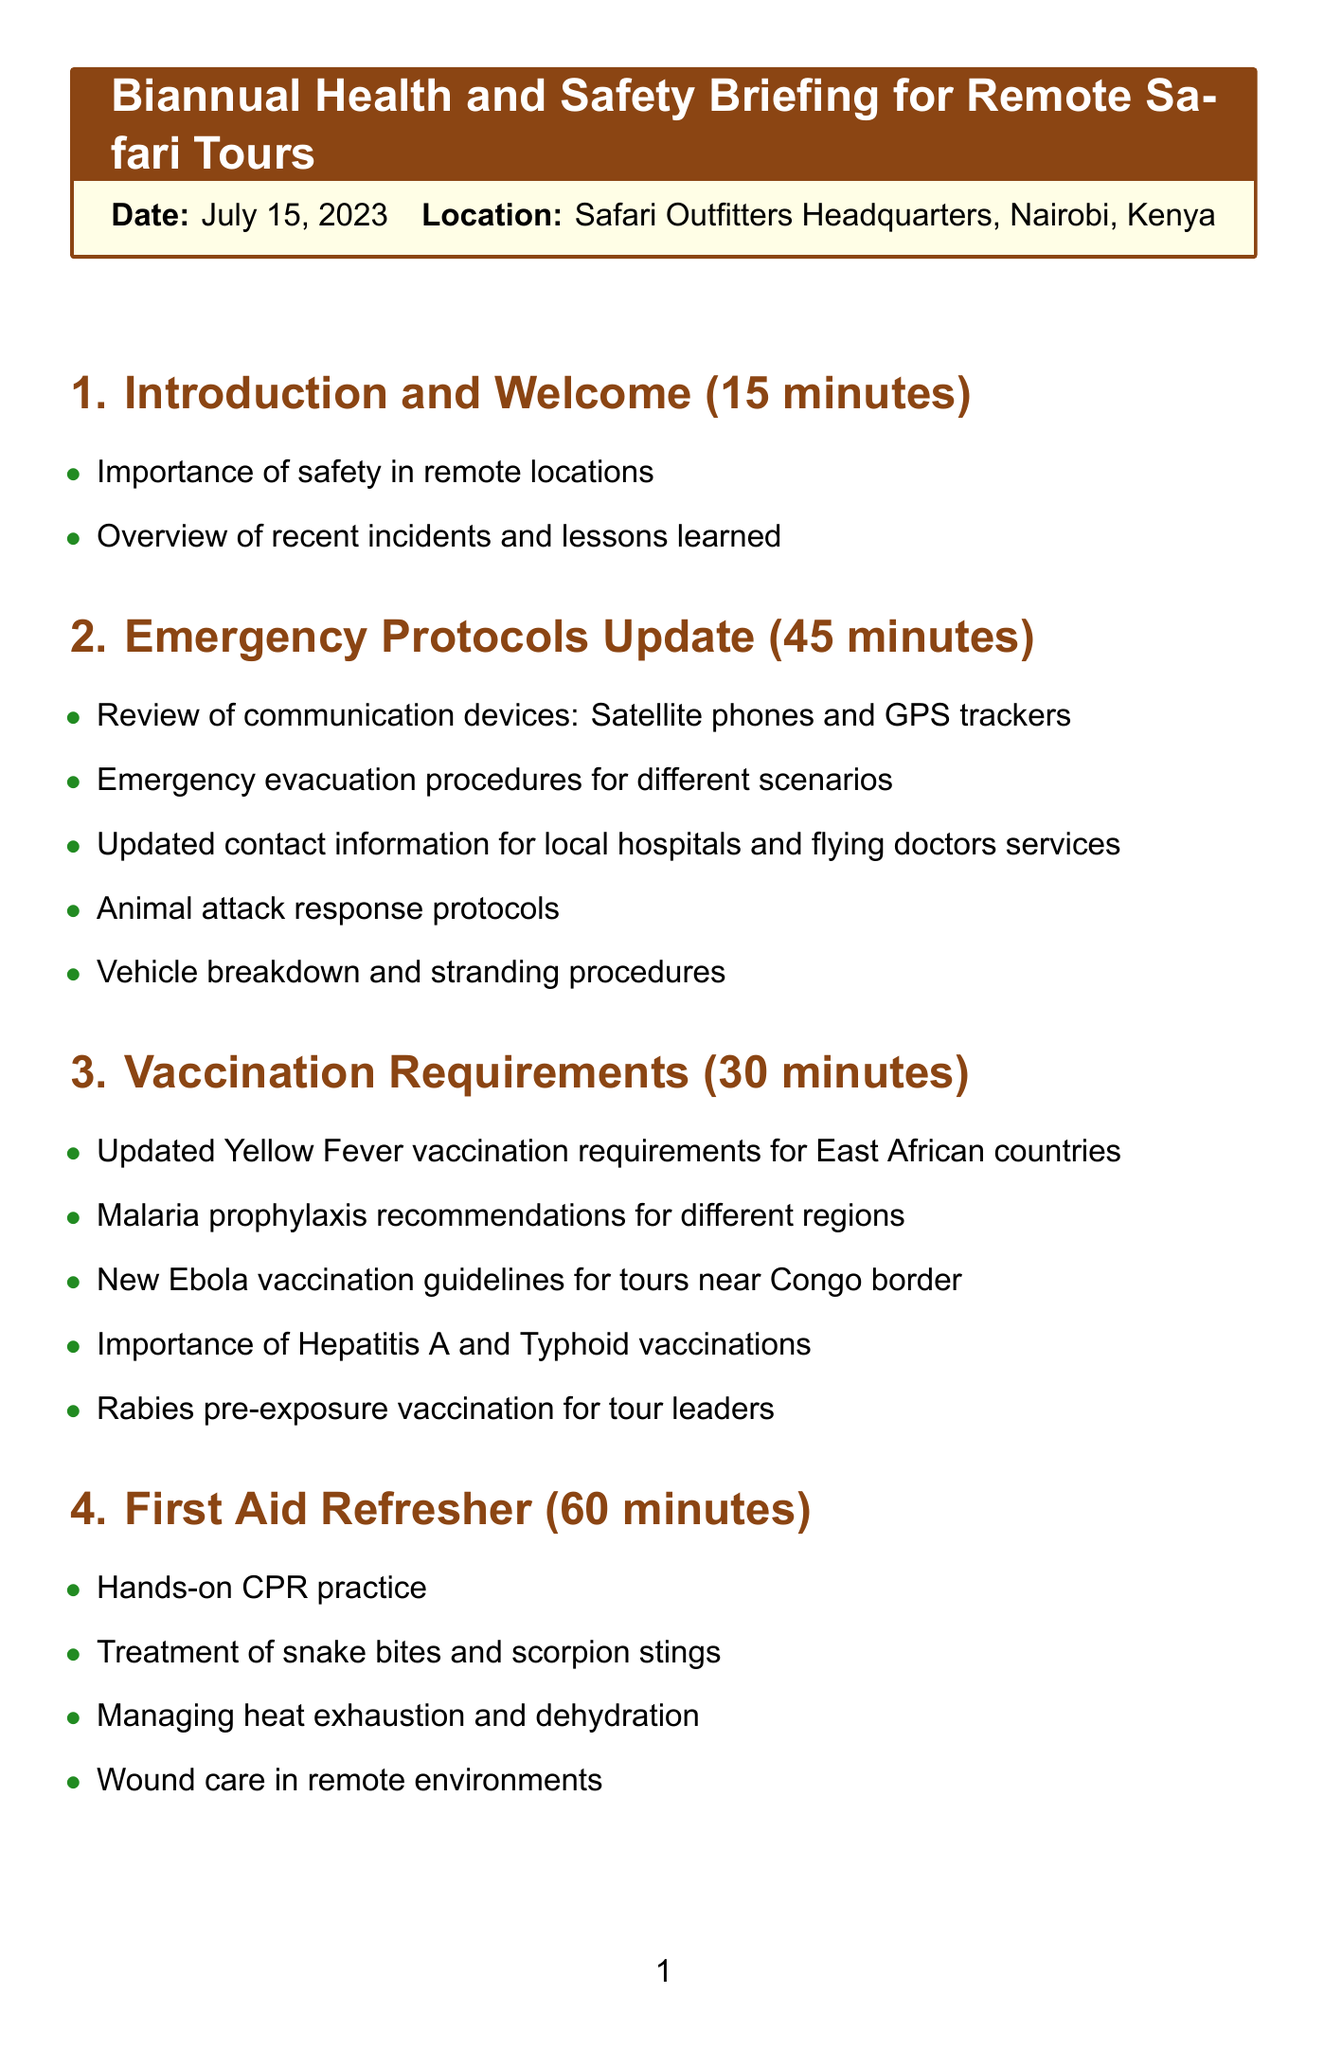What is the date of the briefing? The date of the briefing is clearly stated in the schedule as July 15, 2023.
Answer: July 15, 2023 Where is the briefing taking place? The location of the briefing can be found in the header section of the document, which states it's at Safari Outfitters Headquarters, Nairobi, Kenya.
Answer: Safari Outfitters Headquarters, Nairobi, Kenya How long is the Emergency Protocols Update session? The duration for the Emergency Protocols Update can be found listed directly under its section title in the schedule, which is 45 minutes.
Answer: 45 minutes What new vaccination guidelines are discussed for tours near the Congo border? The information regarding vaccination guidelines near the Congo border is specifically mentioned under the Vaccination Requirements section of the schedule.
Answer: New Ebola vaccination guidelines What is one of the topics covered in the First Aid Refresher? The topics covered in the First Aid Refresher can be located in the corresponding section, with multiple topics listed, one of which is treatment of snake bites and scorpion stings.
Answer: Treatment of snake bites and scorpion stings What principle is emphasized in the Environmental Awareness section? The schedule contains principles under Environmental Awareness, among which is the Leave No Trace principles for safari tours, emphasized in this section.
Answer: Leave No Trace principles How long is the Q&A and Closing Remarks session? The length of the Q&A and Closing Remarks session is stated under its section title as 30 minutes.
Answer: 30 minutes What safety procedures are included for vehicle breakdowns? The document lists various procedures in the Emergency Protocols section, specifically including vehicle breakdown and stranding procedures.
Answer: Vehicle breakdown and stranding procedures 